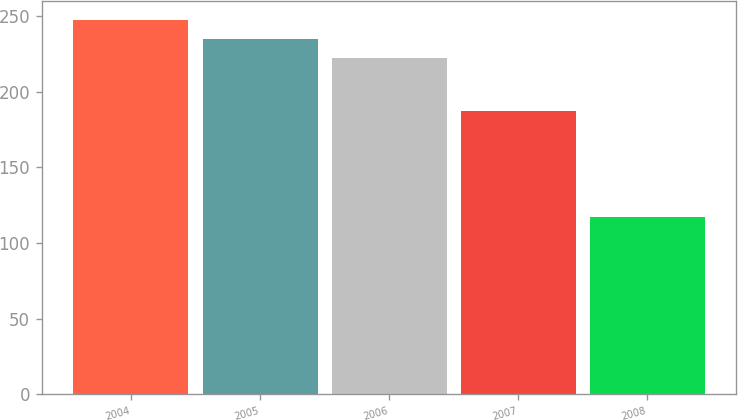<chart> <loc_0><loc_0><loc_500><loc_500><bar_chart><fcel>2004<fcel>2005<fcel>2006<fcel>2007<fcel>2008<nl><fcel>247.6<fcel>235<fcel>222<fcel>187<fcel>117<nl></chart> 